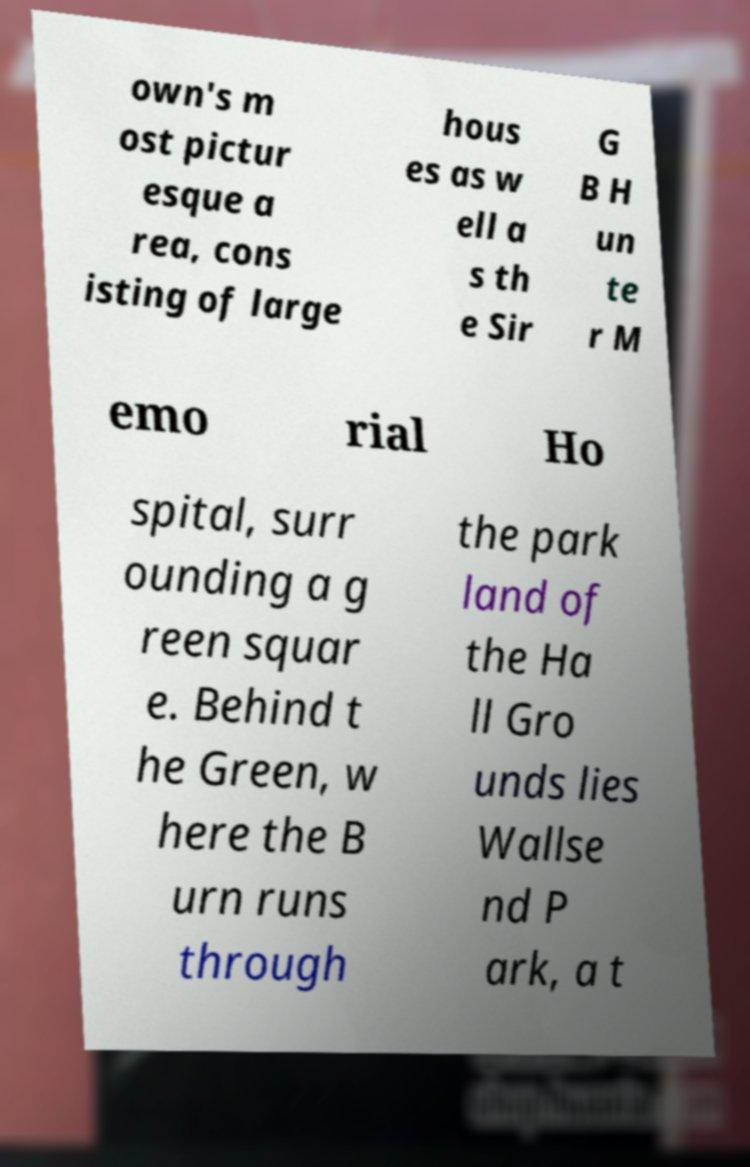Could you extract and type out the text from this image? own's m ost pictur esque a rea, cons isting of large hous es as w ell a s th e Sir G B H un te r M emo rial Ho spital, surr ounding a g reen squar e. Behind t he Green, w here the B urn runs through the park land of the Ha ll Gro unds lies Wallse nd P ark, a t 